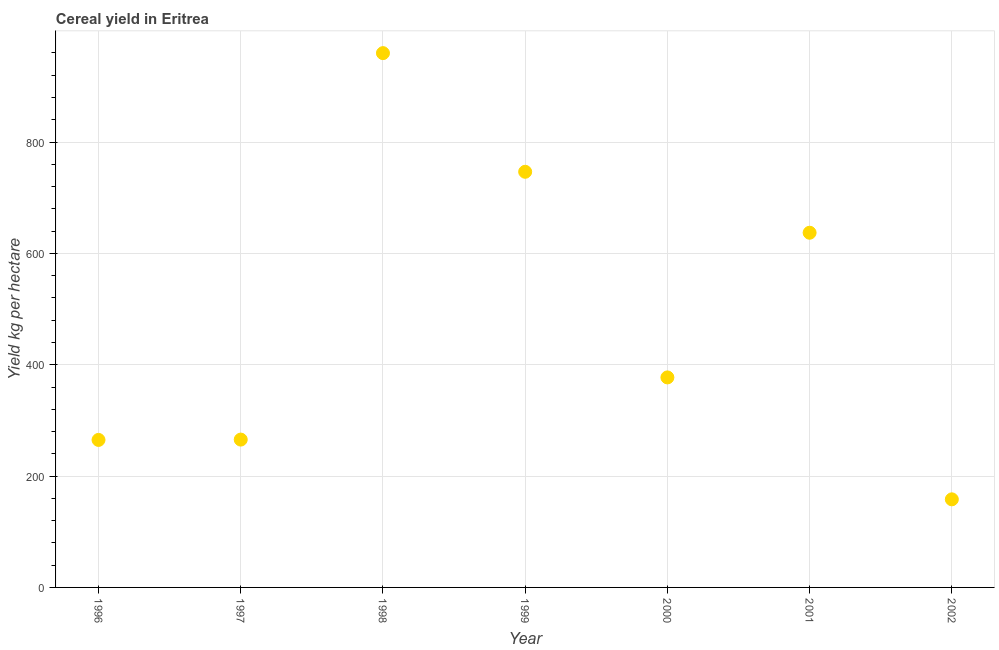What is the cereal yield in 2000?
Provide a short and direct response. 377.22. Across all years, what is the maximum cereal yield?
Ensure brevity in your answer.  959.68. Across all years, what is the minimum cereal yield?
Your response must be concise. 158.23. In which year was the cereal yield minimum?
Keep it short and to the point. 2002. What is the sum of the cereal yield?
Offer a terse response. 3409.28. What is the difference between the cereal yield in 1997 and 1999?
Provide a succinct answer. -481.02. What is the average cereal yield per year?
Your answer should be compact. 487.04. What is the median cereal yield?
Your answer should be very brief. 377.22. Do a majority of the years between 1999 and 1997 (inclusive) have cereal yield greater than 80 kg per hectare?
Make the answer very short. No. What is the ratio of the cereal yield in 1997 to that in 1999?
Provide a succinct answer. 0.36. What is the difference between the highest and the second highest cereal yield?
Offer a very short reply. 213.12. What is the difference between the highest and the lowest cereal yield?
Offer a very short reply. 801.46. Does the cereal yield monotonically increase over the years?
Your response must be concise. No. How many dotlines are there?
Provide a short and direct response. 1. How many years are there in the graph?
Provide a succinct answer. 7. Does the graph contain any zero values?
Make the answer very short. No. What is the title of the graph?
Ensure brevity in your answer.  Cereal yield in Eritrea. What is the label or title of the Y-axis?
Provide a succinct answer. Yield kg per hectare. What is the Yield kg per hectare in 1996?
Your answer should be compact. 264.95. What is the Yield kg per hectare in 1997?
Your answer should be compact. 265.54. What is the Yield kg per hectare in 1998?
Provide a succinct answer. 959.68. What is the Yield kg per hectare in 1999?
Offer a very short reply. 746.57. What is the Yield kg per hectare in 2000?
Provide a short and direct response. 377.22. What is the Yield kg per hectare in 2001?
Your answer should be compact. 637.09. What is the Yield kg per hectare in 2002?
Your answer should be compact. 158.23. What is the difference between the Yield kg per hectare in 1996 and 1997?
Provide a succinct answer. -0.59. What is the difference between the Yield kg per hectare in 1996 and 1998?
Your answer should be very brief. -694.74. What is the difference between the Yield kg per hectare in 1996 and 1999?
Make the answer very short. -481.62. What is the difference between the Yield kg per hectare in 1996 and 2000?
Offer a terse response. -112.27. What is the difference between the Yield kg per hectare in 1996 and 2001?
Provide a short and direct response. -372.14. What is the difference between the Yield kg per hectare in 1996 and 2002?
Offer a terse response. 106.72. What is the difference between the Yield kg per hectare in 1997 and 1998?
Your response must be concise. -694.14. What is the difference between the Yield kg per hectare in 1997 and 1999?
Provide a succinct answer. -481.02. What is the difference between the Yield kg per hectare in 1997 and 2000?
Give a very brief answer. -111.68. What is the difference between the Yield kg per hectare in 1997 and 2001?
Keep it short and to the point. -371.55. What is the difference between the Yield kg per hectare in 1997 and 2002?
Offer a very short reply. 107.31. What is the difference between the Yield kg per hectare in 1998 and 1999?
Offer a terse response. 213.12. What is the difference between the Yield kg per hectare in 1998 and 2000?
Your answer should be very brief. 582.46. What is the difference between the Yield kg per hectare in 1998 and 2001?
Offer a very short reply. 322.6. What is the difference between the Yield kg per hectare in 1998 and 2002?
Offer a very short reply. 801.46. What is the difference between the Yield kg per hectare in 1999 and 2000?
Your response must be concise. 369.34. What is the difference between the Yield kg per hectare in 1999 and 2001?
Your response must be concise. 109.47. What is the difference between the Yield kg per hectare in 1999 and 2002?
Offer a very short reply. 588.34. What is the difference between the Yield kg per hectare in 2000 and 2001?
Your response must be concise. -259.87. What is the difference between the Yield kg per hectare in 2000 and 2002?
Your answer should be compact. 218.99. What is the difference between the Yield kg per hectare in 2001 and 2002?
Ensure brevity in your answer.  478.86. What is the ratio of the Yield kg per hectare in 1996 to that in 1998?
Your answer should be very brief. 0.28. What is the ratio of the Yield kg per hectare in 1996 to that in 1999?
Give a very brief answer. 0.35. What is the ratio of the Yield kg per hectare in 1996 to that in 2000?
Your answer should be compact. 0.7. What is the ratio of the Yield kg per hectare in 1996 to that in 2001?
Your response must be concise. 0.42. What is the ratio of the Yield kg per hectare in 1996 to that in 2002?
Make the answer very short. 1.67. What is the ratio of the Yield kg per hectare in 1997 to that in 1998?
Make the answer very short. 0.28. What is the ratio of the Yield kg per hectare in 1997 to that in 1999?
Give a very brief answer. 0.36. What is the ratio of the Yield kg per hectare in 1997 to that in 2000?
Ensure brevity in your answer.  0.7. What is the ratio of the Yield kg per hectare in 1997 to that in 2001?
Offer a very short reply. 0.42. What is the ratio of the Yield kg per hectare in 1997 to that in 2002?
Provide a succinct answer. 1.68. What is the ratio of the Yield kg per hectare in 1998 to that in 1999?
Provide a succinct answer. 1.28. What is the ratio of the Yield kg per hectare in 1998 to that in 2000?
Your answer should be very brief. 2.54. What is the ratio of the Yield kg per hectare in 1998 to that in 2001?
Ensure brevity in your answer.  1.51. What is the ratio of the Yield kg per hectare in 1998 to that in 2002?
Make the answer very short. 6.07. What is the ratio of the Yield kg per hectare in 1999 to that in 2000?
Provide a short and direct response. 1.98. What is the ratio of the Yield kg per hectare in 1999 to that in 2001?
Provide a succinct answer. 1.17. What is the ratio of the Yield kg per hectare in 1999 to that in 2002?
Ensure brevity in your answer.  4.72. What is the ratio of the Yield kg per hectare in 2000 to that in 2001?
Offer a very short reply. 0.59. What is the ratio of the Yield kg per hectare in 2000 to that in 2002?
Ensure brevity in your answer.  2.38. What is the ratio of the Yield kg per hectare in 2001 to that in 2002?
Give a very brief answer. 4.03. 